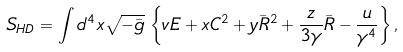Convert formula to latex. <formula><loc_0><loc_0><loc_500><loc_500>S _ { H D } = \int d ^ { 4 } x \sqrt { - { \bar { g } } } \, \left \{ v E + x C ^ { 2 } + y { \bar { R } } ^ { 2 } + \frac { z } { 3 \gamma } { \bar { R } } - \frac { u } { \gamma ^ { 4 } } \right \} ,</formula> 